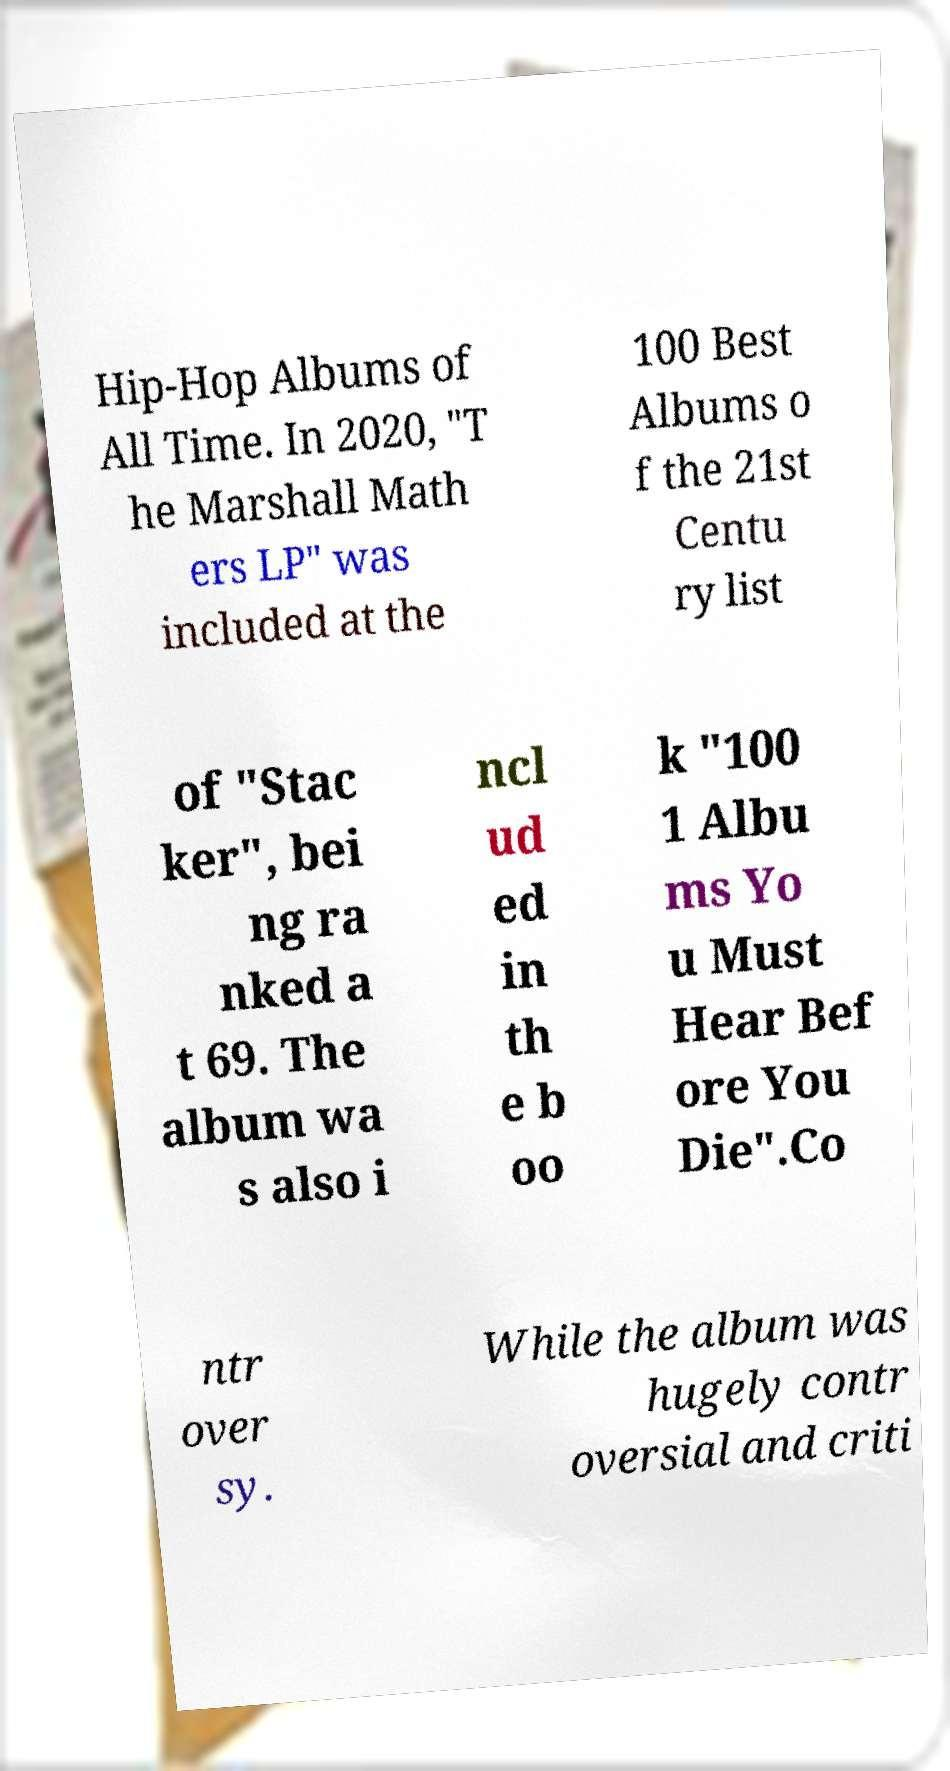Please identify and transcribe the text found in this image. Hip-Hop Albums of All Time. In 2020, "T he Marshall Math ers LP" was included at the 100 Best Albums o f the 21st Centu ry list of "Stac ker", bei ng ra nked a t 69. The album wa s also i ncl ud ed in th e b oo k "100 1 Albu ms Yo u Must Hear Bef ore You Die".Co ntr over sy. While the album was hugely contr oversial and criti 